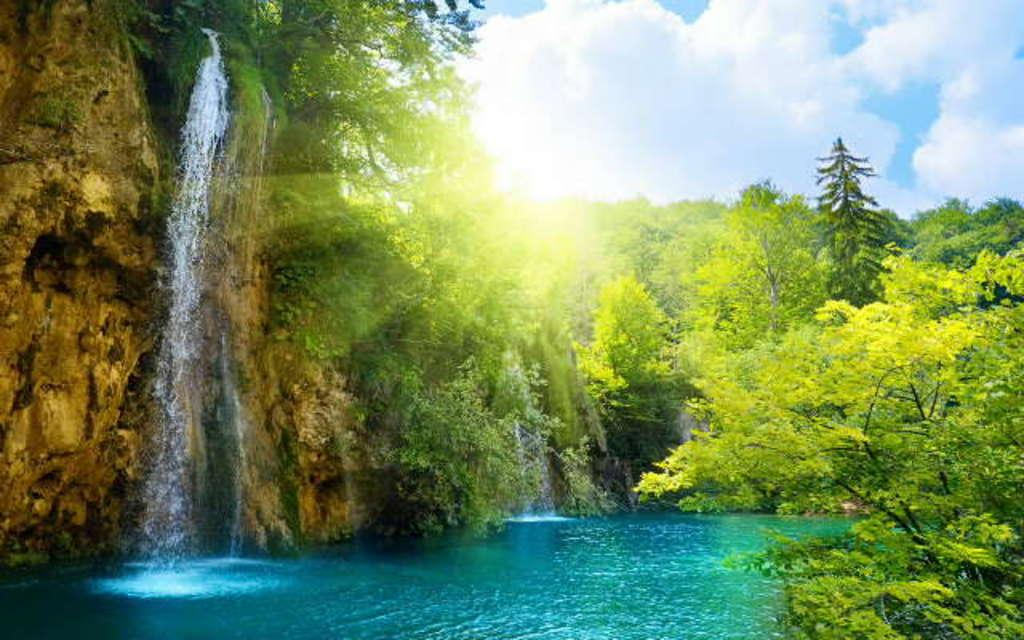What is one of the natural elements present in the image? There is water in the image. What type of vegetation can be seen in the image? There are trees in the image. What can be seen in the sky in the image? Clouds are visible in the image. What else is visible in the sky in the image? The sky is visible in the image. What type of water feature is present in the image? There is a waterfall in the image. What type of chess piece is floating in the waterfall in the image? There is no chess piece present in the image, and therefore no such object can be observed in the waterfall. 